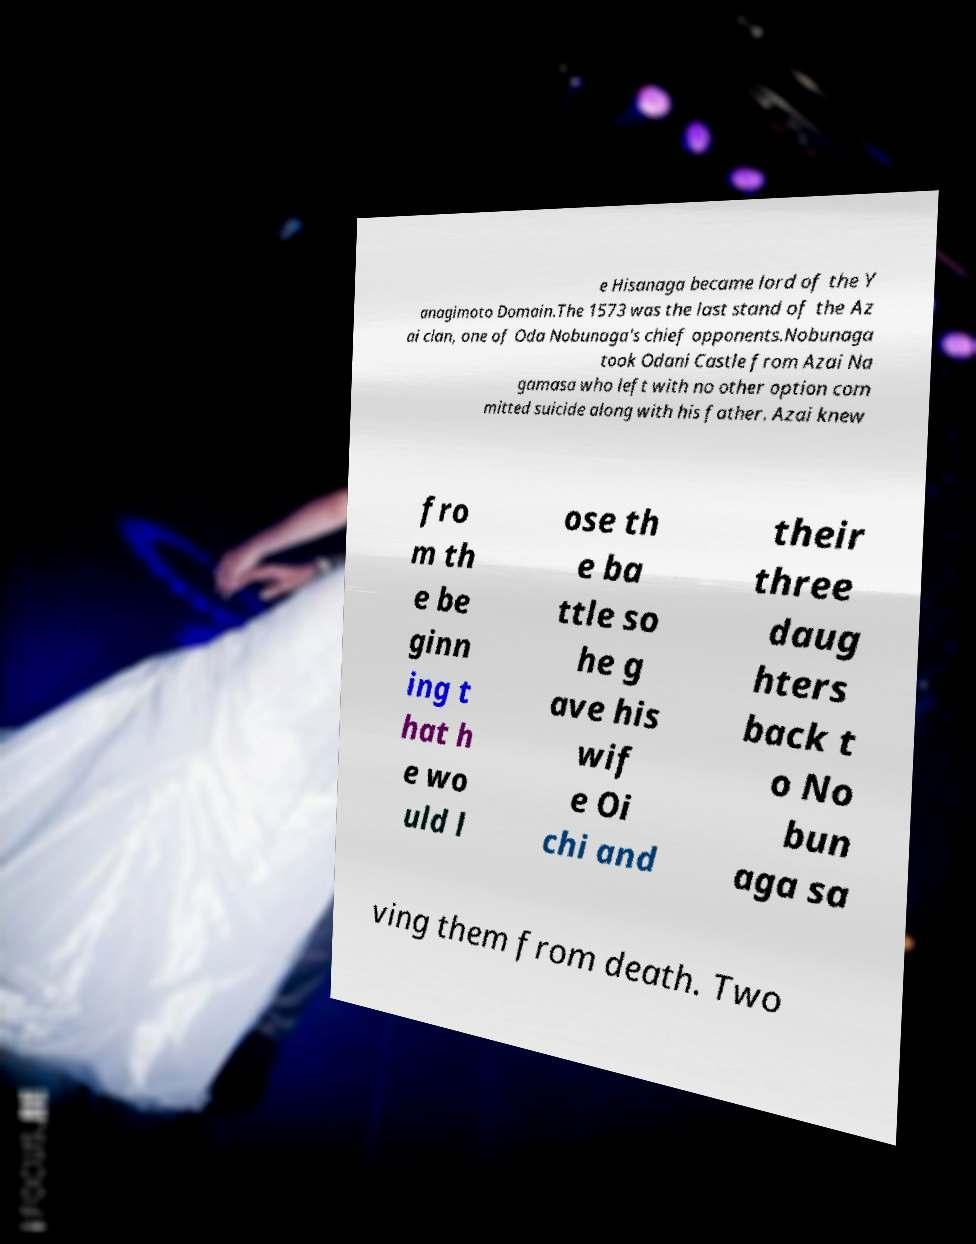Please read and relay the text visible in this image. What does it say? e Hisanaga became lord of the Y anagimoto Domain.The 1573 was the last stand of the Az ai clan, one of Oda Nobunaga's chief opponents.Nobunaga took Odani Castle from Azai Na gamasa who left with no other option com mitted suicide along with his father. Azai knew fro m th e be ginn ing t hat h e wo uld l ose th e ba ttle so he g ave his wif e Oi chi and their three daug hters back t o No bun aga sa ving them from death. Two 